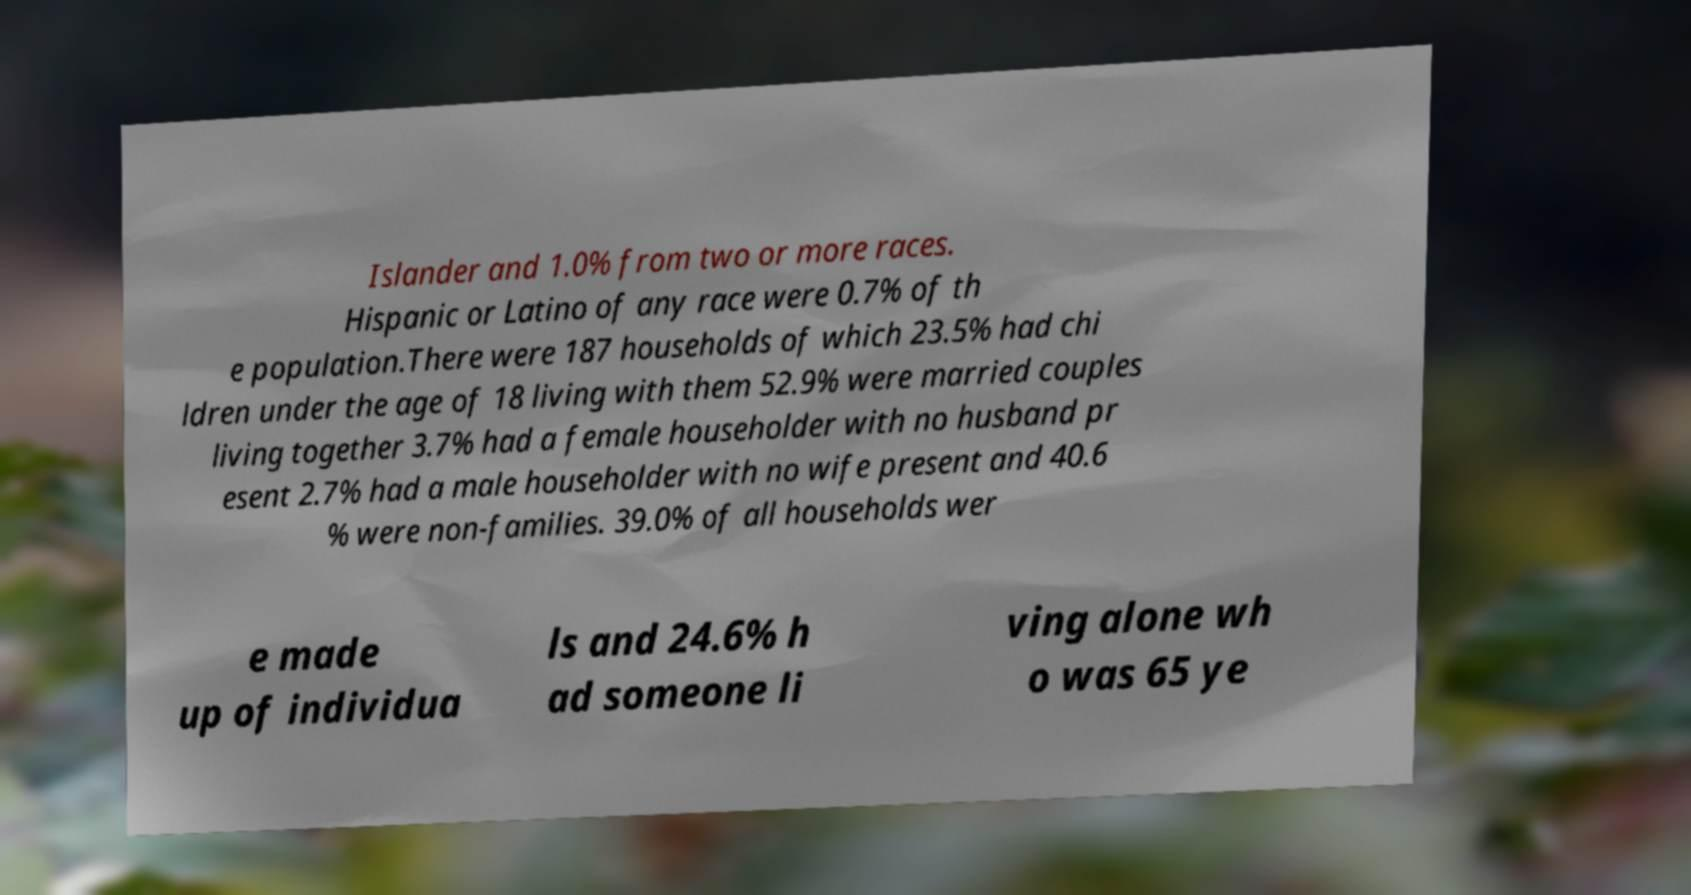Could you assist in decoding the text presented in this image and type it out clearly? Islander and 1.0% from two or more races. Hispanic or Latino of any race were 0.7% of th e population.There were 187 households of which 23.5% had chi ldren under the age of 18 living with them 52.9% were married couples living together 3.7% had a female householder with no husband pr esent 2.7% had a male householder with no wife present and 40.6 % were non-families. 39.0% of all households wer e made up of individua ls and 24.6% h ad someone li ving alone wh o was 65 ye 